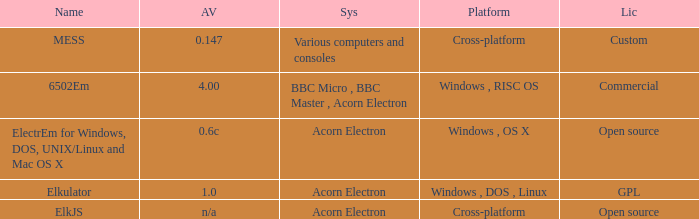What is the structure known as elkjs? Acorn Electron. 